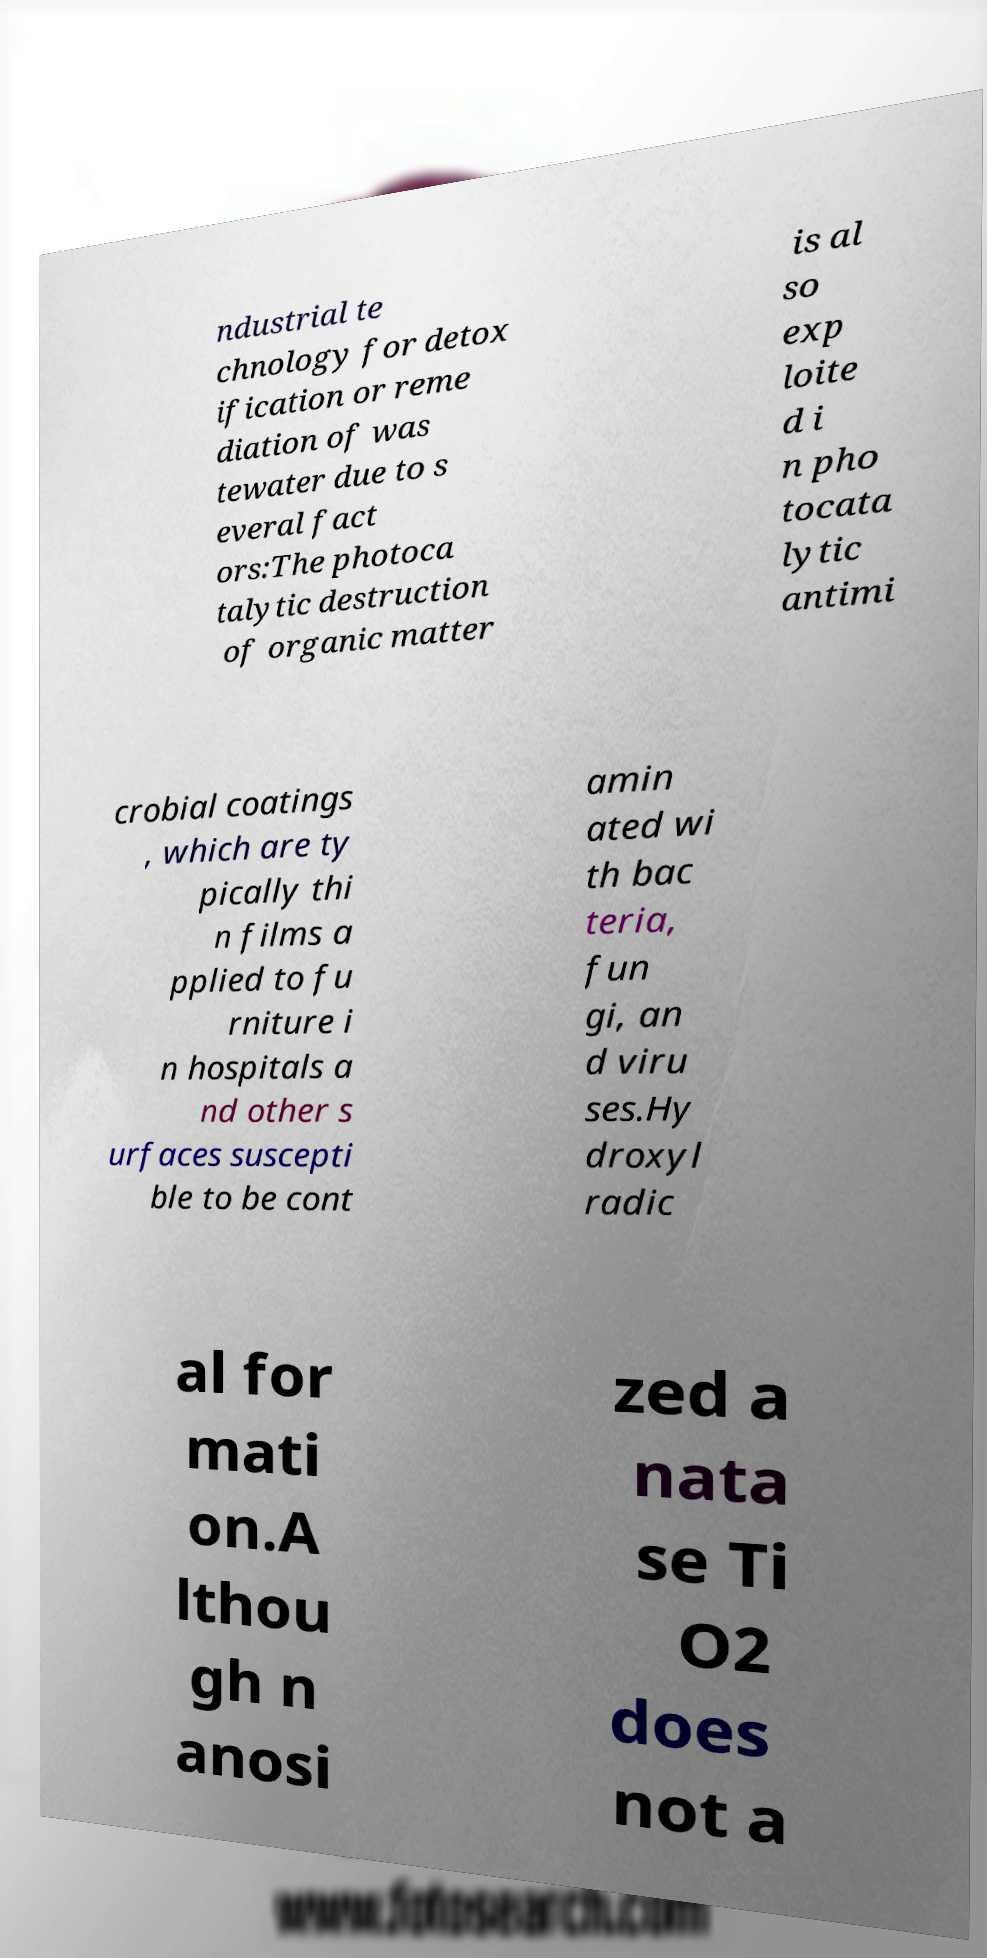Please read and relay the text visible in this image. What does it say? ndustrial te chnology for detox ification or reme diation of was tewater due to s everal fact ors:The photoca talytic destruction of organic matter is al so exp loite d i n pho tocata lytic antimi crobial coatings , which are ty pically thi n films a pplied to fu rniture i n hospitals a nd other s urfaces suscepti ble to be cont amin ated wi th bac teria, fun gi, an d viru ses.Hy droxyl radic al for mati on.A lthou gh n anosi zed a nata se Ti O2 does not a 